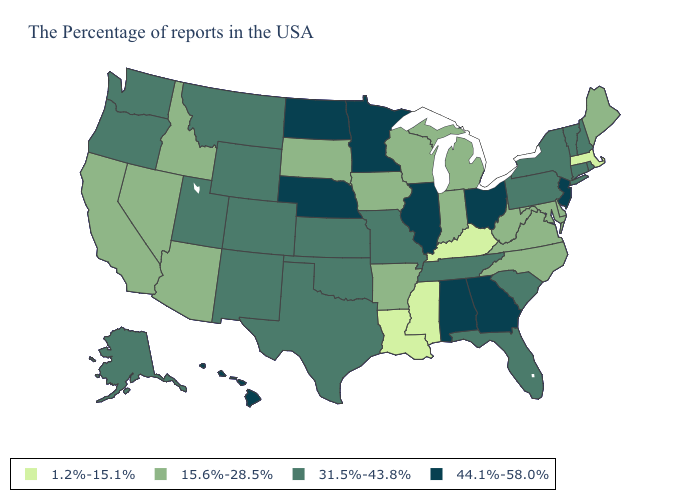Name the states that have a value in the range 15.6%-28.5%?
Short answer required. Maine, Delaware, Maryland, Virginia, North Carolina, West Virginia, Michigan, Indiana, Wisconsin, Arkansas, Iowa, South Dakota, Arizona, Idaho, Nevada, California. What is the value of Minnesota?
Quick response, please. 44.1%-58.0%. What is the value of Mississippi?
Concise answer only. 1.2%-15.1%. How many symbols are there in the legend?
Short answer required. 4. Does Louisiana have the lowest value in the South?
Write a very short answer. Yes. What is the value of New Mexico?
Short answer required. 31.5%-43.8%. Which states have the highest value in the USA?
Give a very brief answer. New Jersey, Ohio, Georgia, Alabama, Illinois, Minnesota, Nebraska, North Dakota, Hawaii. Which states have the lowest value in the West?
Be succinct. Arizona, Idaho, Nevada, California. Name the states that have a value in the range 1.2%-15.1%?
Write a very short answer. Massachusetts, Kentucky, Mississippi, Louisiana. Does Montana have the lowest value in the USA?
Concise answer only. No. What is the value of Nevada?
Quick response, please. 15.6%-28.5%. Which states have the lowest value in the USA?
Give a very brief answer. Massachusetts, Kentucky, Mississippi, Louisiana. Which states hav the highest value in the South?
Answer briefly. Georgia, Alabama. Does the map have missing data?
Answer briefly. No. What is the value of New Jersey?
Short answer required. 44.1%-58.0%. 